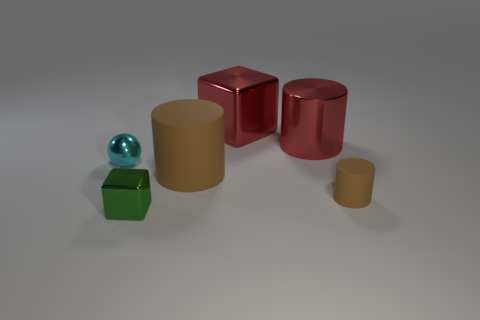Subtract all tiny brown cylinders. How many cylinders are left? 2 Subtract all red balls. How many brown cylinders are left? 2 Add 1 cyan metal balls. How many objects exist? 7 Subtract 1 cylinders. How many cylinders are left? 2 Subtract all red cubes. How many cubes are left? 1 Add 3 green matte objects. How many green matte objects exist? 3 Subtract 0 brown balls. How many objects are left? 6 Subtract all balls. How many objects are left? 5 Subtract all yellow blocks. Subtract all cyan cylinders. How many blocks are left? 2 Subtract all brown cylinders. Subtract all tiny green things. How many objects are left? 3 